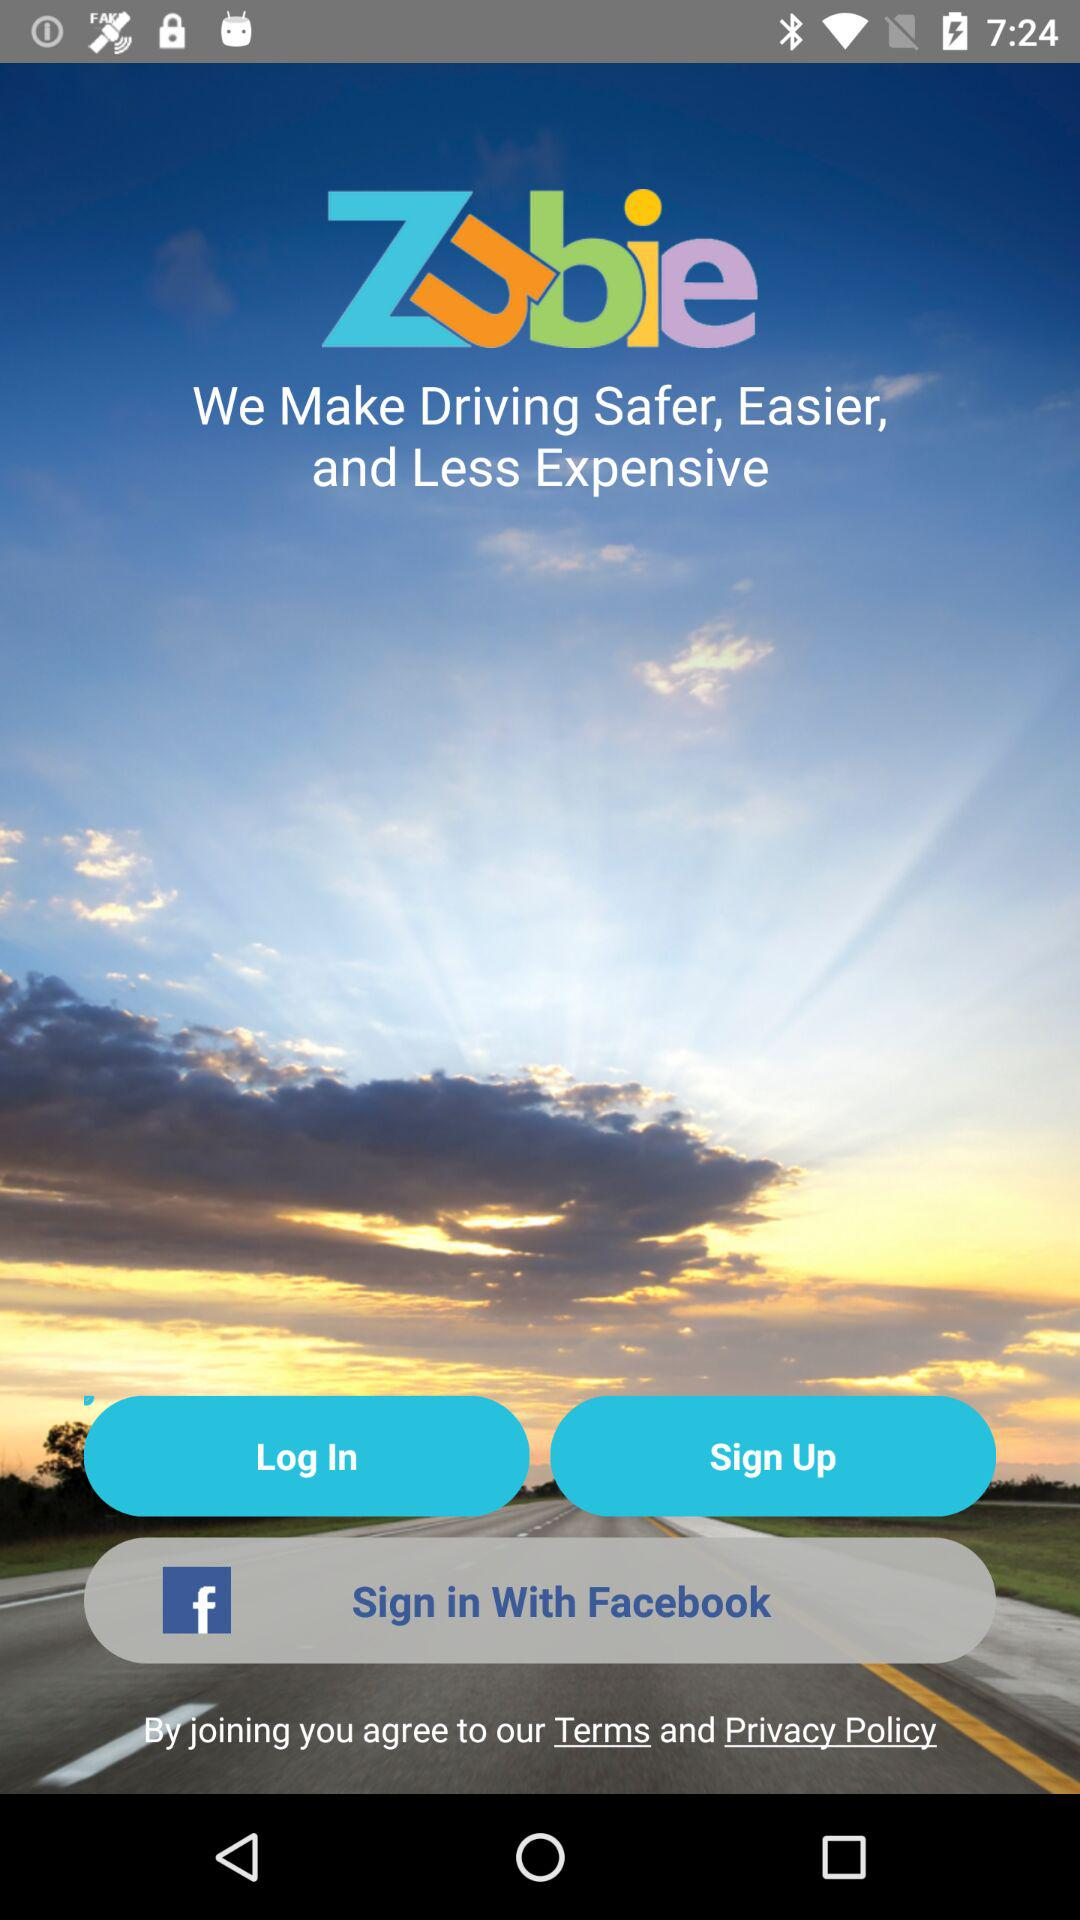What is the app name? The app name is "Zubie". 